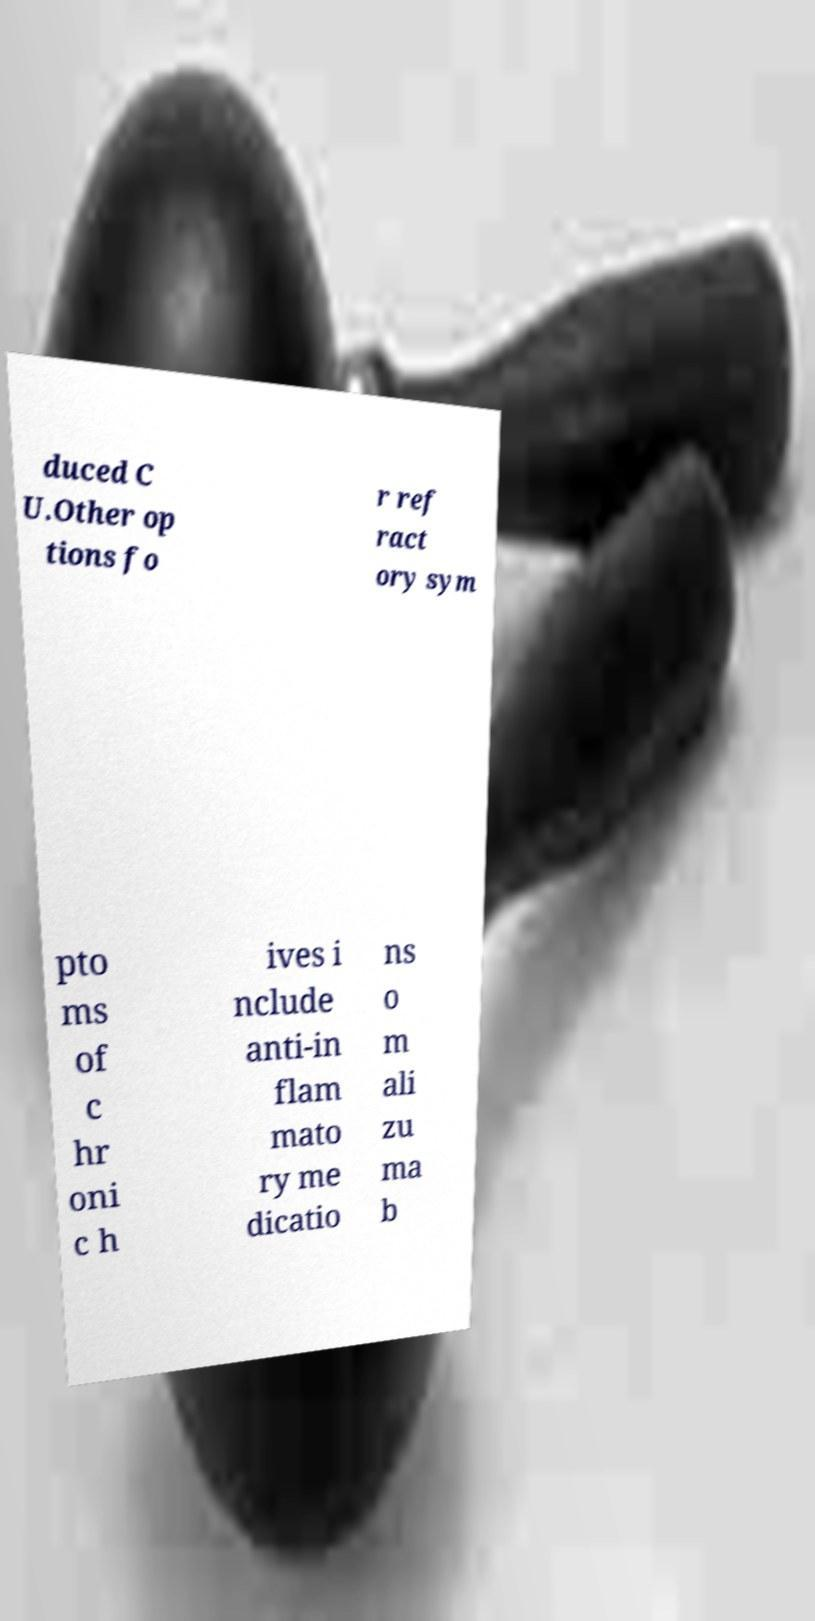Could you assist in decoding the text presented in this image and type it out clearly? duced C U.Other op tions fo r ref ract ory sym pto ms of c hr oni c h ives i nclude anti-in flam mato ry me dicatio ns o m ali zu ma b 